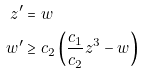Convert formula to latex. <formula><loc_0><loc_0><loc_500><loc_500>z ^ { \prime } & = w \\ w ^ { \prime } & \geq c _ { 2 } \left ( \frac { c _ { 1 } } { c _ { 2 } } z ^ { 3 } - w \right )</formula> 